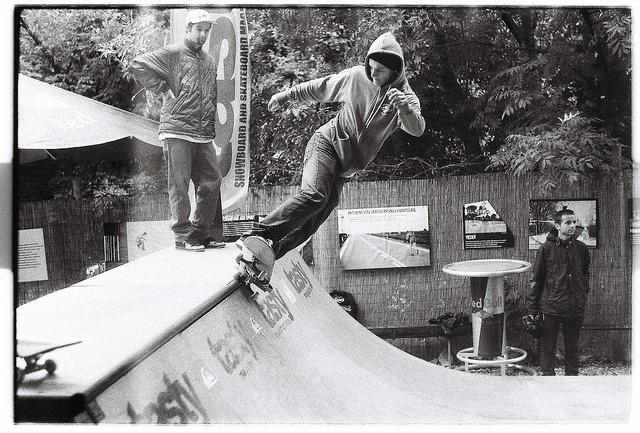What is the man doing?
Concise answer only. Skateboarding. What is the logo by the table?
Be succinct. Red bull. What is the man skating on?
Write a very short answer. Ramp. 